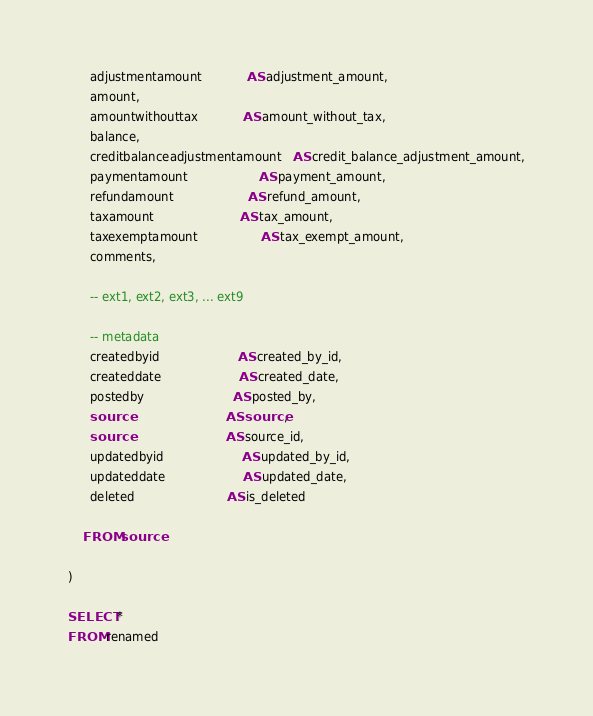Convert code to text. <code><loc_0><loc_0><loc_500><loc_500><_SQL_>      adjustmentamount            AS adjustment_amount,
      amount,
      amountwithouttax            AS amount_without_tax, 
      balance,
      creditbalanceadjustmentamount   AS credit_balance_adjustment_amount,
      paymentamount                   AS payment_amount,
      refundamount                    AS refund_amount,
      taxamount                       AS tax_amount,
      taxexemptamount                 AS tax_exempt_amount,
      comments,

      -- ext1, ext2, ext3, ... ext9

      -- metadata
      createdbyid                     AS created_by_id,
      createddate                     AS created_date,
      postedby                        AS posted_by,
      source                          AS source,
      source                          AS source_id,
      updatedbyid                     AS updated_by_id,
      updateddate                     AS updated_date,
      deleted                         AS is_deleted

    FROM source

)

SELECT *
FROM renamed
</code> 